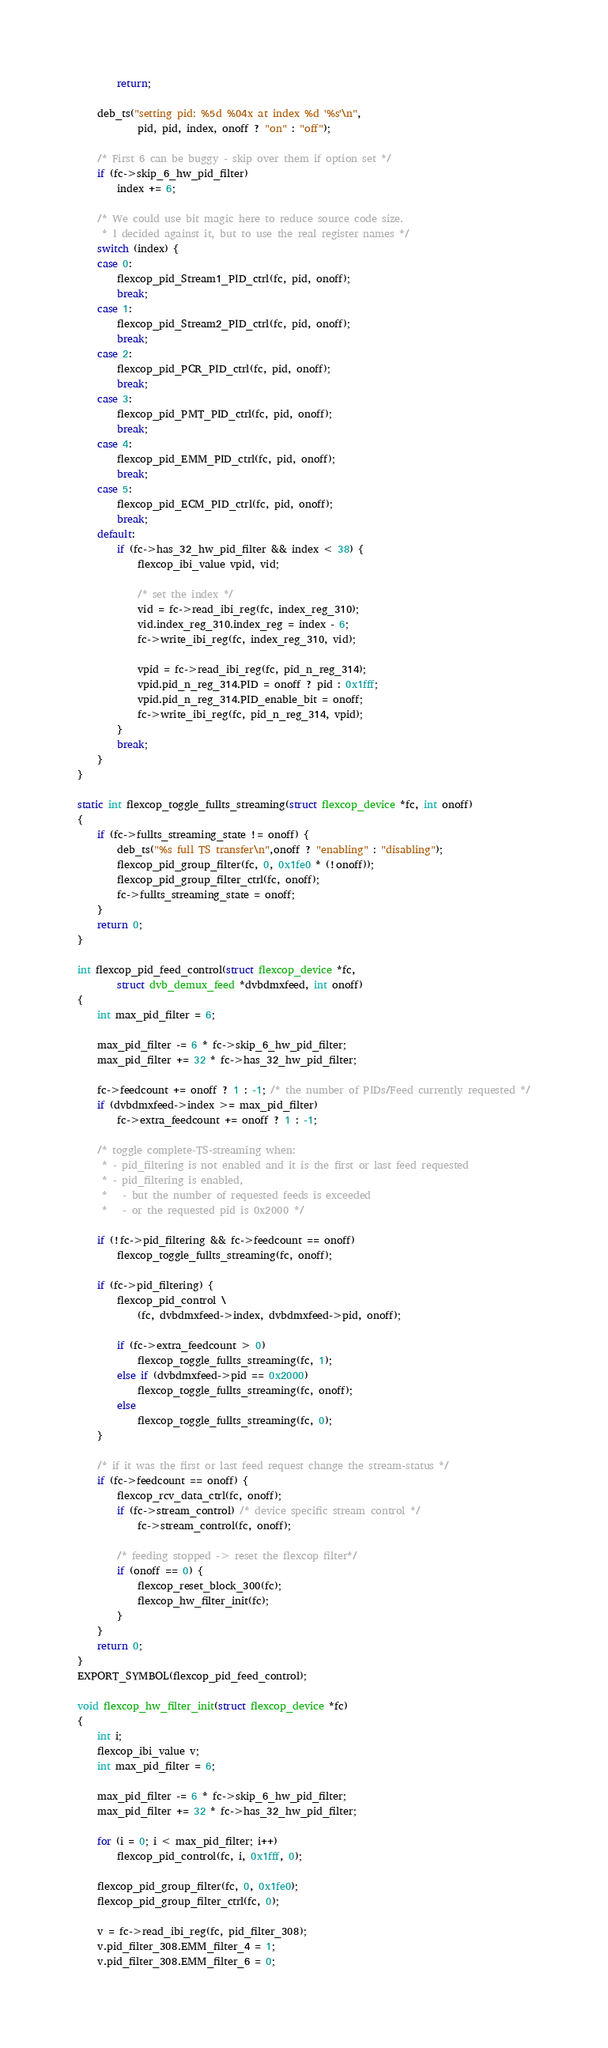<code> <loc_0><loc_0><loc_500><loc_500><_C_>		return;

	deb_ts("setting pid: %5d %04x at index %d '%s'\n",
			pid, pid, index, onoff ? "on" : "off");

	/* First 6 can be buggy - skip over them if option set */
	if (fc->skip_6_hw_pid_filter)
		index += 6;

	/* We could use bit magic here to reduce source code size.
	 * I decided against it, but to use the real register names */
	switch (index) {
	case 0:
		flexcop_pid_Stream1_PID_ctrl(fc, pid, onoff);
		break;
	case 1:
		flexcop_pid_Stream2_PID_ctrl(fc, pid, onoff);
		break;
	case 2:
		flexcop_pid_PCR_PID_ctrl(fc, pid, onoff);
		break;
	case 3:
		flexcop_pid_PMT_PID_ctrl(fc, pid, onoff);
		break;
	case 4:
		flexcop_pid_EMM_PID_ctrl(fc, pid, onoff);
		break;
	case 5:
		flexcop_pid_ECM_PID_ctrl(fc, pid, onoff);
		break;
	default:
		if (fc->has_32_hw_pid_filter && index < 38) {
			flexcop_ibi_value vpid, vid;

			/* set the index */
			vid = fc->read_ibi_reg(fc, index_reg_310);
			vid.index_reg_310.index_reg = index - 6;
			fc->write_ibi_reg(fc, index_reg_310, vid);

			vpid = fc->read_ibi_reg(fc, pid_n_reg_314);
			vpid.pid_n_reg_314.PID = onoff ? pid : 0x1fff;
			vpid.pid_n_reg_314.PID_enable_bit = onoff;
			fc->write_ibi_reg(fc, pid_n_reg_314, vpid);
		}
		break;
	}
}

static int flexcop_toggle_fullts_streaming(struct flexcop_device *fc, int onoff)
{
	if (fc->fullts_streaming_state != onoff) {
		deb_ts("%s full TS transfer\n",onoff ? "enabling" : "disabling");
		flexcop_pid_group_filter(fc, 0, 0x1fe0 * (!onoff));
		flexcop_pid_group_filter_ctrl(fc, onoff);
		fc->fullts_streaming_state = onoff;
	}
	return 0;
}

int flexcop_pid_feed_control(struct flexcop_device *fc,
		struct dvb_demux_feed *dvbdmxfeed, int onoff)
{
	int max_pid_filter = 6;

	max_pid_filter -= 6 * fc->skip_6_hw_pid_filter;
	max_pid_filter += 32 * fc->has_32_hw_pid_filter;

	fc->feedcount += onoff ? 1 : -1; /* the number of PIDs/Feed currently requested */
	if (dvbdmxfeed->index >= max_pid_filter)
		fc->extra_feedcount += onoff ? 1 : -1;

	/* toggle complete-TS-streaming when:
	 * - pid_filtering is not enabled and it is the first or last feed requested
	 * - pid_filtering is enabled,
	 *   - but the number of requested feeds is exceeded
	 *   - or the requested pid is 0x2000 */

	if (!fc->pid_filtering && fc->feedcount == onoff)
		flexcop_toggle_fullts_streaming(fc, onoff);

	if (fc->pid_filtering) {
		flexcop_pid_control \
			(fc, dvbdmxfeed->index, dvbdmxfeed->pid, onoff);

		if (fc->extra_feedcount > 0)
			flexcop_toggle_fullts_streaming(fc, 1);
		else if (dvbdmxfeed->pid == 0x2000)
			flexcop_toggle_fullts_streaming(fc, onoff);
		else
			flexcop_toggle_fullts_streaming(fc, 0);
	}

	/* if it was the first or last feed request change the stream-status */
	if (fc->feedcount == onoff) {
		flexcop_rcv_data_ctrl(fc, onoff);
		if (fc->stream_control) /* device specific stream control */
			fc->stream_control(fc, onoff);

		/* feeding stopped -> reset the flexcop filter*/
		if (onoff == 0) {
			flexcop_reset_block_300(fc);
			flexcop_hw_filter_init(fc);
		}
	}
	return 0;
}
EXPORT_SYMBOL(flexcop_pid_feed_control);

void flexcop_hw_filter_init(struct flexcop_device *fc)
{
	int i;
	flexcop_ibi_value v;
	int max_pid_filter = 6;

	max_pid_filter -= 6 * fc->skip_6_hw_pid_filter;
	max_pid_filter += 32 * fc->has_32_hw_pid_filter;

	for (i = 0; i < max_pid_filter; i++)
		flexcop_pid_control(fc, i, 0x1fff, 0);

	flexcop_pid_group_filter(fc, 0, 0x1fe0);
	flexcop_pid_group_filter_ctrl(fc, 0);

	v = fc->read_ibi_reg(fc, pid_filter_308);
	v.pid_filter_308.EMM_filter_4 = 1;
	v.pid_filter_308.EMM_filter_6 = 0;</code> 